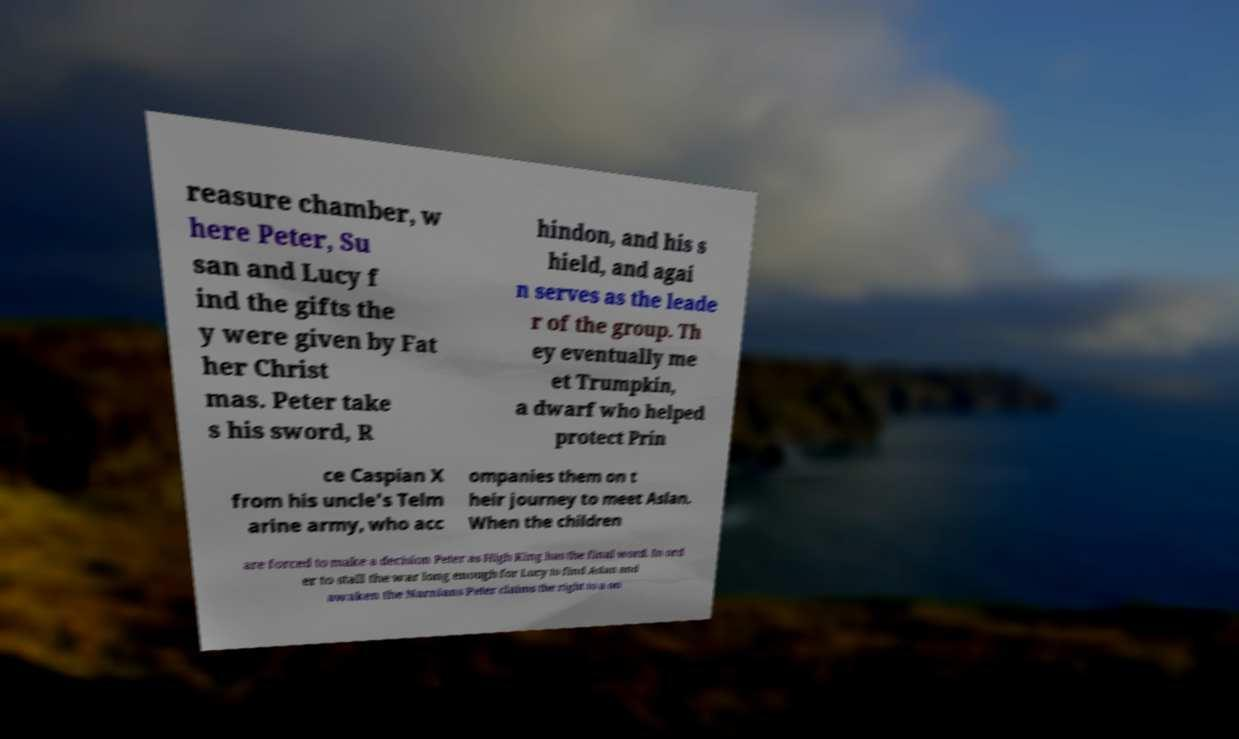There's text embedded in this image that I need extracted. Can you transcribe it verbatim? reasure chamber, w here Peter, Su san and Lucy f ind the gifts the y were given by Fat her Christ mas. Peter take s his sword, R hindon, and his s hield, and agai n serves as the leade r of the group. Th ey eventually me et Trumpkin, a dwarf who helped protect Prin ce Caspian X from his uncle's Telm arine army, who acc ompanies them on t heir journey to meet Aslan. When the children are forced to make a decision Peter as High King has the final word. In ord er to stall the war long enough for Lucy to find Aslan and awaken the Narnians Peter claims the right to a on 